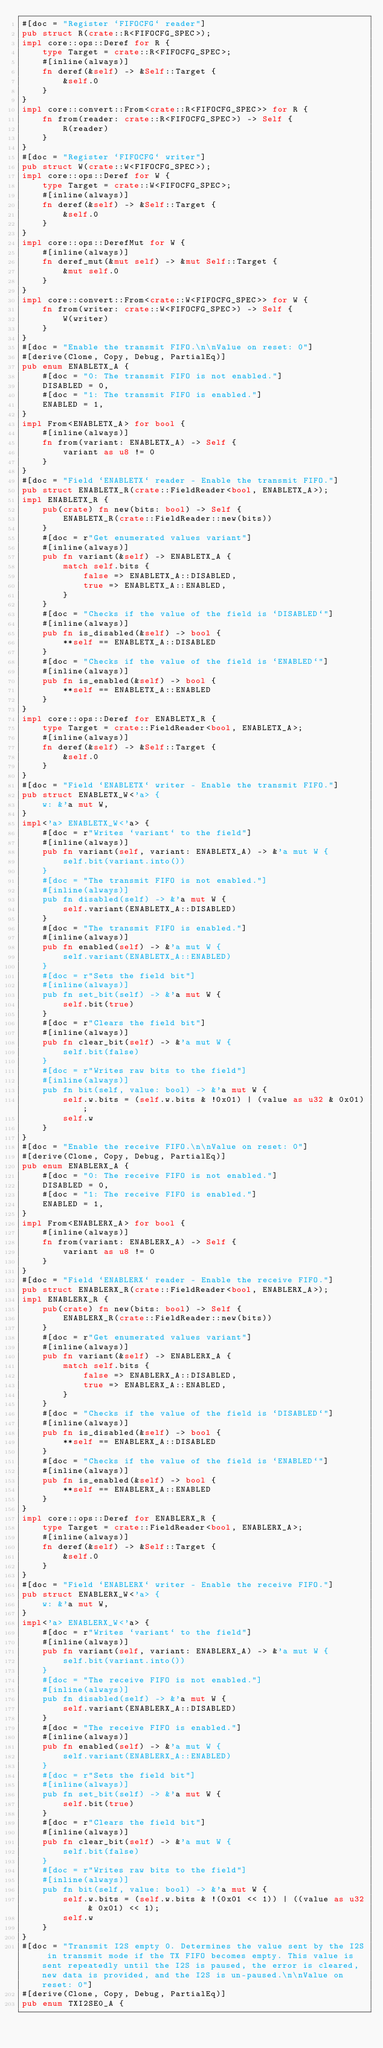<code> <loc_0><loc_0><loc_500><loc_500><_Rust_>#[doc = "Register `FIFOCFG` reader"]
pub struct R(crate::R<FIFOCFG_SPEC>);
impl core::ops::Deref for R {
    type Target = crate::R<FIFOCFG_SPEC>;
    #[inline(always)]
    fn deref(&self) -> &Self::Target {
        &self.0
    }
}
impl core::convert::From<crate::R<FIFOCFG_SPEC>> for R {
    fn from(reader: crate::R<FIFOCFG_SPEC>) -> Self {
        R(reader)
    }
}
#[doc = "Register `FIFOCFG` writer"]
pub struct W(crate::W<FIFOCFG_SPEC>);
impl core::ops::Deref for W {
    type Target = crate::W<FIFOCFG_SPEC>;
    #[inline(always)]
    fn deref(&self) -> &Self::Target {
        &self.0
    }
}
impl core::ops::DerefMut for W {
    #[inline(always)]
    fn deref_mut(&mut self) -> &mut Self::Target {
        &mut self.0
    }
}
impl core::convert::From<crate::W<FIFOCFG_SPEC>> for W {
    fn from(writer: crate::W<FIFOCFG_SPEC>) -> Self {
        W(writer)
    }
}
#[doc = "Enable the transmit FIFO.\n\nValue on reset: 0"]
#[derive(Clone, Copy, Debug, PartialEq)]
pub enum ENABLETX_A {
    #[doc = "0: The transmit FIFO is not enabled."]
    DISABLED = 0,
    #[doc = "1: The transmit FIFO is enabled."]
    ENABLED = 1,
}
impl From<ENABLETX_A> for bool {
    #[inline(always)]
    fn from(variant: ENABLETX_A) -> Self {
        variant as u8 != 0
    }
}
#[doc = "Field `ENABLETX` reader - Enable the transmit FIFO."]
pub struct ENABLETX_R(crate::FieldReader<bool, ENABLETX_A>);
impl ENABLETX_R {
    pub(crate) fn new(bits: bool) -> Self {
        ENABLETX_R(crate::FieldReader::new(bits))
    }
    #[doc = r"Get enumerated values variant"]
    #[inline(always)]
    pub fn variant(&self) -> ENABLETX_A {
        match self.bits {
            false => ENABLETX_A::DISABLED,
            true => ENABLETX_A::ENABLED,
        }
    }
    #[doc = "Checks if the value of the field is `DISABLED`"]
    #[inline(always)]
    pub fn is_disabled(&self) -> bool {
        **self == ENABLETX_A::DISABLED
    }
    #[doc = "Checks if the value of the field is `ENABLED`"]
    #[inline(always)]
    pub fn is_enabled(&self) -> bool {
        **self == ENABLETX_A::ENABLED
    }
}
impl core::ops::Deref for ENABLETX_R {
    type Target = crate::FieldReader<bool, ENABLETX_A>;
    #[inline(always)]
    fn deref(&self) -> &Self::Target {
        &self.0
    }
}
#[doc = "Field `ENABLETX` writer - Enable the transmit FIFO."]
pub struct ENABLETX_W<'a> {
    w: &'a mut W,
}
impl<'a> ENABLETX_W<'a> {
    #[doc = r"Writes `variant` to the field"]
    #[inline(always)]
    pub fn variant(self, variant: ENABLETX_A) -> &'a mut W {
        self.bit(variant.into())
    }
    #[doc = "The transmit FIFO is not enabled."]
    #[inline(always)]
    pub fn disabled(self) -> &'a mut W {
        self.variant(ENABLETX_A::DISABLED)
    }
    #[doc = "The transmit FIFO is enabled."]
    #[inline(always)]
    pub fn enabled(self) -> &'a mut W {
        self.variant(ENABLETX_A::ENABLED)
    }
    #[doc = r"Sets the field bit"]
    #[inline(always)]
    pub fn set_bit(self) -> &'a mut W {
        self.bit(true)
    }
    #[doc = r"Clears the field bit"]
    #[inline(always)]
    pub fn clear_bit(self) -> &'a mut W {
        self.bit(false)
    }
    #[doc = r"Writes raw bits to the field"]
    #[inline(always)]
    pub fn bit(self, value: bool) -> &'a mut W {
        self.w.bits = (self.w.bits & !0x01) | (value as u32 & 0x01);
        self.w
    }
}
#[doc = "Enable the receive FIFO.\n\nValue on reset: 0"]
#[derive(Clone, Copy, Debug, PartialEq)]
pub enum ENABLERX_A {
    #[doc = "0: The receive FIFO is not enabled."]
    DISABLED = 0,
    #[doc = "1: The receive FIFO is enabled."]
    ENABLED = 1,
}
impl From<ENABLERX_A> for bool {
    #[inline(always)]
    fn from(variant: ENABLERX_A) -> Self {
        variant as u8 != 0
    }
}
#[doc = "Field `ENABLERX` reader - Enable the receive FIFO."]
pub struct ENABLERX_R(crate::FieldReader<bool, ENABLERX_A>);
impl ENABLERX_R {
    pub(crate) fn new(bits: bool) -> Self {
        ENABLERX_R(crate::FieldReader::new(bits))
    }
    #[doc = r"Get enumerated values variant"]
    #[inline(always)]
    pub fn variant(&self) -> ENABLERX_A {
        match self.bits {
            false => ENABLERX_A::DISABLED,
            true => ENABLERX_A::ENABLED,
        }
    }
    #[doc = "Checks if the value of the field is `DISABLED`"]
    #[inline(always)]
    pub fn is_disabled(&self) -> bool {
        **self == ENABLERX_A::DISABLED
    }
    #[doc = "Checks if the value of the field is `ENABLED`"]
    #[inline(always)]
    pub fn is_enabled(&self) -> bool {
        **self == ENABLERX_A::ENABLED
    }
}
impl core::ops::Deref for ENABLERX_R {
    type Target = crate::FieldReader<bool, ENABLERX_A>;
    #[inline(always)]
    fn deref(&self) -> &Self::Target {
        &self.0
    }
}
#[doc = "Field `ENABLERX` writer - Enable the receive FIFO."]
pub struct ENABLERX_W<'a> {
    w: &'a mut W,
}
impl<'a> ENABLERX_W<'a> {
    #[doc = r"Writes `variant` to the field"]
    #[inline(always)]
    pub fn variant(self, variant: ENABLERX_A) -> &'a mut W {
        self.bit(variant.into())
    }
    #[doc = "The receive FIFO is not enabled."]
    #[inline(always)]
    pub fn disabled(self) -> &'a mut W {
        self.variant(ENABLERX_A::DISABLED)
    }
    #[doc = "The receive FIFO is enabled."]
    #[inline(always)]
    pub fn enabled(self) -> &'a mut W {
        self.variant(ENABLERX_A::ENABLED)
    }
    #[doc = r"Sets the field bit"]
    #[inline(always)]
    pub fn set_bit(self) -> &'a mut W {
        self.bit(true)
    }
    #[doc = r"Clears the field bit"]
    #[inline(always)]
    pub fn clear_bit(self) -> &'a mut W {
        self.bit(false)
    }
    #[doc = r"Writes raw bits to the field"]
    #[inline(always)]
    pub fn bit(self, value: bool) -> &'a mut W {
        self.w.bits = (self.w.bits & !(0x01 << 1)) | ((value as u32 & 0x01) << 1);
        self.w
    }
}
#[doc = "Transmit I2S empty 0. Determines the value sent by the I2S in transmit mode if the TX FIFO becomes empty. This value is sent repeatedly until the I2S is paused, the error is cleared, new data is provided, and the I2S is un-paused.\n\nValue on reset: 0"]
#[derive(Clone, Copy, Debug, PartialEq)]
pub enum TXI2SE0_A {</code> 